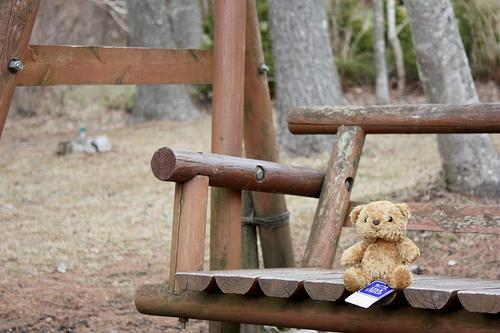Question: who is pictured?
Choices:
A. No one.
B. Adults.
C. Children.
D. A squirrel.
Answer with the letter. Answer: A Question: what color is the bear?
Choices:
A. Black.
B. Light brown.
C. White.
D. Dark brown.
Answer with the letter. Answer: B 